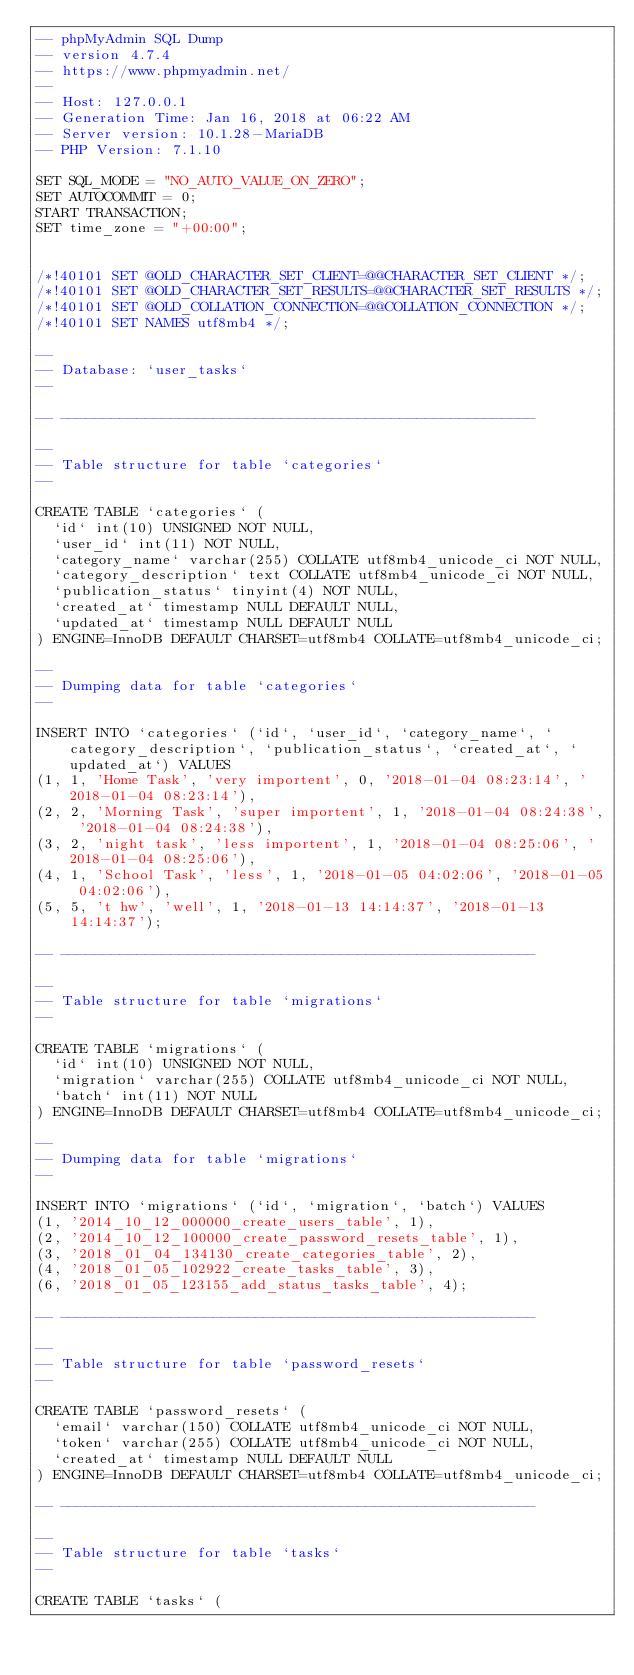Convert code to text. <code><loc_0><loc_0><loc_500><loc_500><_SQL_>-- phpMyAdmin SQL Dump
-- version 4.7.4
-- https://www.phpmyadmin.net/
--
-- Host: 127.0.0.1
-- Generation Time: Jan 16, 2018 at 06:22 AM
-- Server version: 10.1.28-MariaDB
-- PHP Version: 7.1.10

SET SQL_MODE = "NO_AUTO_VALUE_ON_ZERO";
SET AUTOCOMMIT = 0;
START TRANSACTION;
SET time_zone = "+00:00";


/*!40101 SET @OLD_CHARACTER_SET_CLIENT=@@CHARACTER_SET_CLIENT */;
/*!40101 SET @OLD_CHARACTER_SET_RESULTS=@@CHARACTER_SET_RESULTS */;
/*!40101 SET @OLD_COLLATION_CONNECTION=@@COLLATION_CONNECTION */;
/*!40101 SET NAMES utf8mb4 */;

--
-- Database: `user_tasks`
--

-- --------------------------------------------------------

--
-- Table structure for table `categories`
--

CREATE TABLE `categories` (
  `id` int(10) UNSIGNED NOT NULL,
  `user_id` int(11) NOT NULL,
  `category_name` varchar(255) COLLATE utf8mb4_unicode_ci NOT NULL,
  `category_description` text COLLATE utf8mb4_unicode_ci NOT NULL,
  `publication_status` tinyint(4) NOT NULL,
  `created_at` timestamp NULL DEFAULT NULL,
  `updated_at` timestamp NULL DEFAULT NULL
) ENGINE=InnoDB DEFAULT CHARSET=utf8mb4 COLLATE=utf8mb4_unicode_ci;

--
-- Dumping data for table `categories`
--

INSERT INTO `categories` (`id`, `user_id`, `category_name`, `category_description`, `publication_status`, `created_at`, `updated_at`) VALUES
(1, 1, 'Home Task', 'very importent', 0, '2018-01-04 08:23:14', '2018-01-04 08:23:14'),
(2, 2, 'Morning Task', 'super importent', 1, '2018-01-04 08:24:38', '2018-01-04 08:24:38'),
(3, 2, 'night task', 'less importent', 1, '2018-01-04 08:25:06', '2018-01-04 08:25:06'),
(4, 1, 'School Task', 'less', 1, '2018-01-05 04:02:06', '2018-01-05 04:02:06'),
(5, 5, 't hw', 'well', 1, '2018-01-13 14:14:37', '2018-01-13 14:14:37');

-- --------------------------------------------------------

--
-- Table structure for table `migrations`
--

CREATE TABLE `migrations` (
  `id` int(10) UNSIGNED NOT NULL,
  `migration` varchar(255) COLLATE utf8mb4_unicode_ci NOT NULL,
  `batch` int(11) NOT NULL
) ENGINE=InnoDB DEFAULT CHARSET=utf8mb4 COLLATE=utf8mb4_unicode_ci;

--
-- Dumping data for table `migrations`
--

INSERT INTO `migrations` (`id`, `migration`, `batch`) VALUES
(1, '2014_10_12_000000_create_users_table', 1),
(2, '2014_10_12_100000_create_password_resets_table', 1),
(3, '2018_01_04_134130_create_categories_table', 2),
(4, '2018_01_05_102922_create_tasks_table', 3),
(6, '2018_01_05_123155_add_status_tasks_table', 4);

-- --------------------------------------------------------

--
-- Table structure for table `password_resets`
--

CREATE TABLE `password_resets` (
  `email` varchar(150) COLLATE utf8mb4_unicode_ci NOT NULL,
  `token` varchar(255) COLLATE utf8mb4_unicode_ci NOT NULL,
  `created_at` timestamp NULL DEFAULT NULL
) ENGINE=InnoDB DEFAULT CHARSET=utf8mb4 COLLATE=utf8mb4_unicode_ci;

-- --------------------------------------------------------

--
-- Table structure for table `tasks`
--

CREATE TABLE `tasks` (</code> 